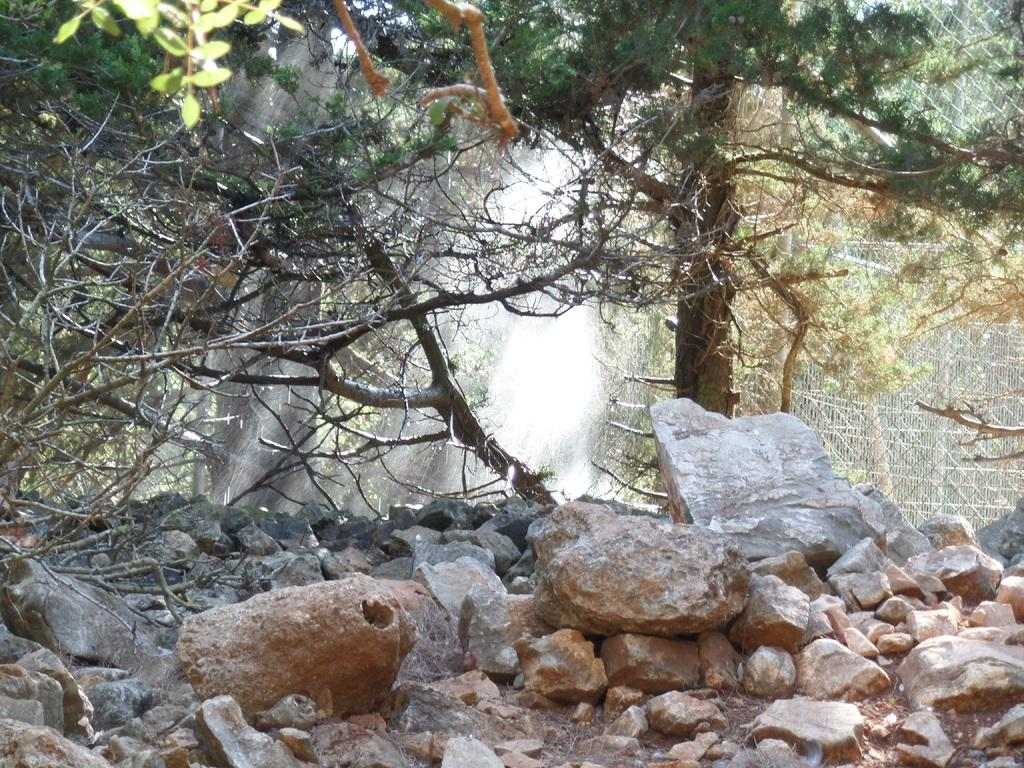What type of natural elements can be seen in the image? There are trees in the image. What type of geological features are present at the bottom of the image? There are rocks at the bottom of the image. What can be seen on the right side of the image? There is a mesh on the right side of the image. How many chickens are roaming around the trees in the image? There are no chickens present in the image; it only features trees, rocks, and a mesh. What degree of difficulty is associated with the camp shown in the image? There is no camp present in the image, so it is not possible to determine the degree of difficulty associated with it. 